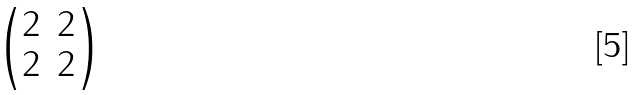<formula> <loc_0><loc_0><loc_500><loc_500>\begin{pmatrix} 2 & 2 \\ 2 & 2 \end{pmatrix}</formula> 